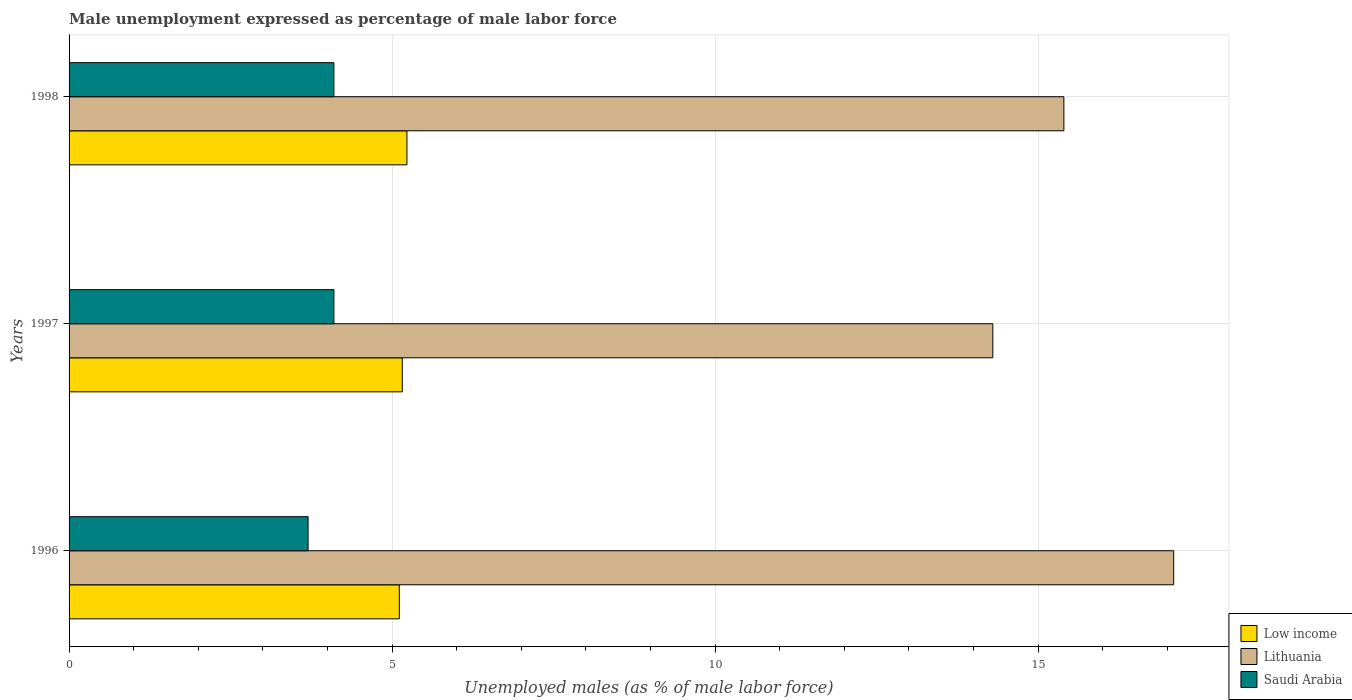How many different coloured bars are there?
Give a very brief answer. 3. How many groups of bars are there?
Your response must be concise. 3. Are the number of bars on each tick of the Y-axis equal?
Your response must be concise. Yes. How many bars are there on the 3rd tick from the top?
Make the answer very short. 3. How many bars are there on the 3rd tick from the bottom?
Your answer should be compact. 3. What is the unemployment in males in in Lithuania in 1997?
Offer a terse response. 14.3. Across all years, what is the maximum unemployment in males in in Low income?
Keep it short and to the point. 5.23. Across all years, what is the minimum unemployment in males in in Saudi Arabia?
Offer a very short reply. 3.7. In which year was the unemployment in males in in Saudi Arabia maximum?
Keep it short and to the point. 1997. In which year was the unemployment in males in in Lithuania minimum?
Your response must be concise. 1997. What is the total unemployment in males in in Low income in the graph?
Your answer should be very brief. 15.5. What is the difference between the unemployment in males in in Low income in 1996 and the unemployment in males in in Saudi Arabia in 1997?
Provide a succinct answer. 1.01. What is the average unemployment in males in in Lithuania per year?
Provide a short and direct response. 15.6. In the year 1996, what is the difference between the unemployment in males in in Lithuania and unemployment in males in in Low income?
Make the answer very short. 11.99. What is the ratio of the unemployment in males in in Saudi Arabia in 1996 to that in 1998?
Your response must be concise. 0.9. Is the unemployment in males in in Saudi Arabia in 1996 less than that in 1998?
Make the answer very short. Yes. What is the difference between the highest and the second highest unemployment in males in in Saudi Arabia?
Offer a terse response. 0. What is the difference between the highest and the lowest unemployment in males in in Lithuania?
Your response must be concise. 2.8. In how many years, is the unemployment in males in in Saudi Arabia greater than the average unemployment in males in in Saudi Arabia taken over all years?
Provide a succinct answer. 2. What does the 3rd bar from the top in 1997 represents?
Provide a succinct answer. Low income. What does the 3rd bar from the bottom in 1997 represents?
Your answer should be compact. Saudi Arabia. Are all the bars in the graph horizontal?
Offer a terse response. Yes. Does the graph contain any zero values?
Offer a terse response. No. Does the graph contain grids?
Make the answer very short. Yes. Where does the legend appear in the graph?
Ensure brevity in your answer.  Bottom right. What is the title of the graph?
Ensure brevity in your answer.  Male unemployment expressed as percentage of male labor force. What is the label or title of the X-axis?
Offer a very short reply. Unemployed males (as % of male labor force). What is the Unemployed males (as % of male labor force) in Low income in 1996?
Your answer should be compact. 5.11. What is the Unemployed males (as % of male labor force) of Lithuania in 1996?
Offer a terse response. 17.1. What is the Unemployed males (as % of male labor force) in Saudi Arabia in 1996?
Give a very brief answer. 3.7. What is the Unemployed males (as % of male labor force) in Low income in 1997?
Make the answer very short. 5.16. What is the Unemployed males (as % of male labor force) in Lithuania in 1997?
Your response must be concise. 14.3. What is the Unemployed males (as % of male labor force) of Saudi Arabia in 1997?
Your answer should be compact. 4.1. What is the Unemployed males (as % of male labor force) of Low income in 1998?
Ensure brevity in your answer.  5.23. What is the Unemployed males (as % of male labor force) of Lithuania in 1998?
Your response must be concise. 15.4. What is the Unemployed males (as % of male labor force) of Saudi Arabia in 1998?
Provide a short and direct response. 4.1. Across all years, what is the maximum Unemployed males (as % of male labor force) of Low income?
Provide a short and direct response. 5.23. Across all years, what is the maximum Unemployed males (as % of male labor force) in Lithuania?
Give a very brief answer. 17.1. Across all years, what is the maximum Unemployed males (as % of male labor force) of Saudi Arabia?
Ensure brevity in your answer.  4.1. Across all years, what is the minimum Unemployed males (as % of male labor force) in Low income?
Offer a very short reply. 5.11. Across all years, what is the minimum Unemployed males (as % of male labor force) in Lithuania?
Your answer should be compact. 14.3. Across all years, what is the minimum Unemployed males (as % of male labor force) of Saudi Arabia?
Make the answer very short. 3.7. What is the total Unemployed males (as % of male labor force) of Low income in the graph?
Provide a short and direct response. 15.5. What is the total Unemployed males (as % of male labor force) of Lithuania in the graph?
Offer a very short reply. 46.8. What is the difference between the Unemployed males (as % of male labor force) in Low income in 1996 and that in 1997?
Give a very brief answer. -0.05. What is the difference between the Unemployed males (as % of male labor force) in Lithuania in 1996 and that in 1997?
Offer a terse response. 2.8. What is the difference between the Unemployed males (as % of male labor force) of Saudi Arabia in 1996 and that in 1997?
Ensure brevity in your answer.  -0.4. What is the difference between the Unemployed males (as % of male labor force) in Low income in 1996 and that in 1998?
Give a very brief answer. -0.12. What is the difference between the Unemployed males (as % of male labor force) of Low income in 1997 and that in 1998?
Your response must be concise. -0.07. What is the difference between the Unemployed males (as % of male labor force) in Low income in 1996 and the Unemployed males (as % of male labor force) in Lithuania in 1997?
Keep it short and to the point. -9.19. What is the difference between the Unemployed males (as % of male labor force) in Low income in 1996 and the Unemployed males (as % of male labor force) in Saudi Arabia in 1997?
Give a very brief answer. 1.01. What is the difference between the Unemployed males (as % of male labor force) in Lithuania in 1996 and the Unemployed males (as % of male labor force) in Saudi Arabia in 1997?
Provide a succinct answer. 13. What is the difference between the Unemployed males (as % of male labor force) in Low income in 1996 and the Unemployed males (as % of male labor force) in Lithuania in 1998?
Ensure brevity in your answer.  -10.29. What is the difference between the Unemployed males (as % of male labor force) of Low income in 1996 and the Unemployed males (as % of male labor force) of Saudi Arabia in 1998?
Provide a short and direct response. 1.01. What is the difference between the Unemployed males (as % of male labor force) of Low income in 1997 and the Unemployed males (as % of male labor force) of Lithuania in 1998?
Offer a terse response. -10.24. What is the difference between the Unemployed males (as % of male labor force) of Low income in 1997 and the Unemployed males (as % of male labor force) of Saudi Arabia in 1998?
Offer a terse response. 1.06. What is the average Unemployed males (as % of male labor force) in Low income per year?
Provide a succinct answer. 5.17. What is the average Unemployed males (as % of male labor force) of Lithuania per year?
Offer a very short reply. 15.6. What is the average Unemployed males (as % of male labor force) of Saudi Arabia per year?
Provide a succinct answer. 3.97. In the year 1996, what is the difference between the Unemployed males (as % of male labor force) of Low income and Unemployed males (as % of male labor force) of Lithuania?
Offer a terse response. -11.99. In the year 1996, what is the difference between the Unemployed males (as % of male labor force) of Low income and Unemployed males (as % of male labor force) of Saudi Arabia?
Keep it short and to the point. 1.41. In the year 1996, what is the difference between the Unemployed males (as % of male labor force) of Lithuania and Unemployed males (as % of male labor force) of Saudi Arabia?
Give a very brief answer. 13.4. In the year 1997, what is the difference between the Unemployed males (as % of male labor force) in Low income and Unemployed males (as % of male labor force) in Lithuania?
Your response must be concise. -9.14. In the year 1997, what is the difference between the Unemployed males (as % of male labor force) in Low income and Unemployed males (as % of male labor force) in Saudi Arabia?
Your response must be concise. 1.06. In the year 1997, what is the difference between the Unemployed males (as % of male labor force) in Lithuania and Unemployed males (as % of male labor force) in Saudi Arabia?
Your answer should be very brief. 10.2. In the year 1998, what is the difference between the Unemployed males (as % of male labor force) in Low income and Unemployed males (as % of male labor force) in Lithuania?
Offer a terse response. -10.17. In the year 1998, what is the difference between the Unemployed males (as % of male labor force) of Low income and Unemployed males (as % of male labor force) of Saudi Arabia?
Keep it short and to the point. 1.13. In the year 1998, what is the difference between the Unemployed males (as % of male labor force) of Lithuania and Unemployed males (as % of male labor force) of Saudi Arabia?
Offer a very short reply. 11.3. What is the ratio of the Unemployed males (as % of male labor force) of Lithuania in 1996 to that in 1997?
Offer a terse response. 1.2. What is the ratio of the Unemployed males (as % of male labor force) in Saudi Arabia in 1996 to that in 1997?
Your response must be concise. 0.9. What is the ratio of the Unemployed males (as % of male labor force) of Low income in 1996 to that in 1998?
Give a very brief answer. 0.98. What is the ratio of the Unemployed males (as % of male labor force) of Lithuania in 1996 to that in 1998?
Make the answer very short. 1.11. What is the ratio of the Unemployed males (as % of male labor force) of Saudi Arabia in 1996 to that in 1998?
Provide a short and direct response. 0.9. What is the ratio of the Unemployed males (as % of male labor force) in Low income in 1997 to that in 1998?
Ensure brevity in your answer.  0.99. What is the ratio of the Unemployed males (as % of male labor force) of Saudi Arabia in 1997 to that in 1998?
Keep it short and to the point. 1. What is the difference between the highest and the second highest Unemployed males (as % of male labor force) in Low income?
Make the answer very short. 0.07. What is the difference between the highest and the second highest Unemployed males (as % of male labor force) in Lithuania?
Provide a short and direct response. 1.7. What is the difference between the highest and the second highest Unemployed males (as % of male labor force) of Saudi Arabia?
Your answer should be very brief. 0. What is the difference between the highest and the lowest Unemployed males (as % of male labor force) of Low income?
Your response must be concise. 0.12. 